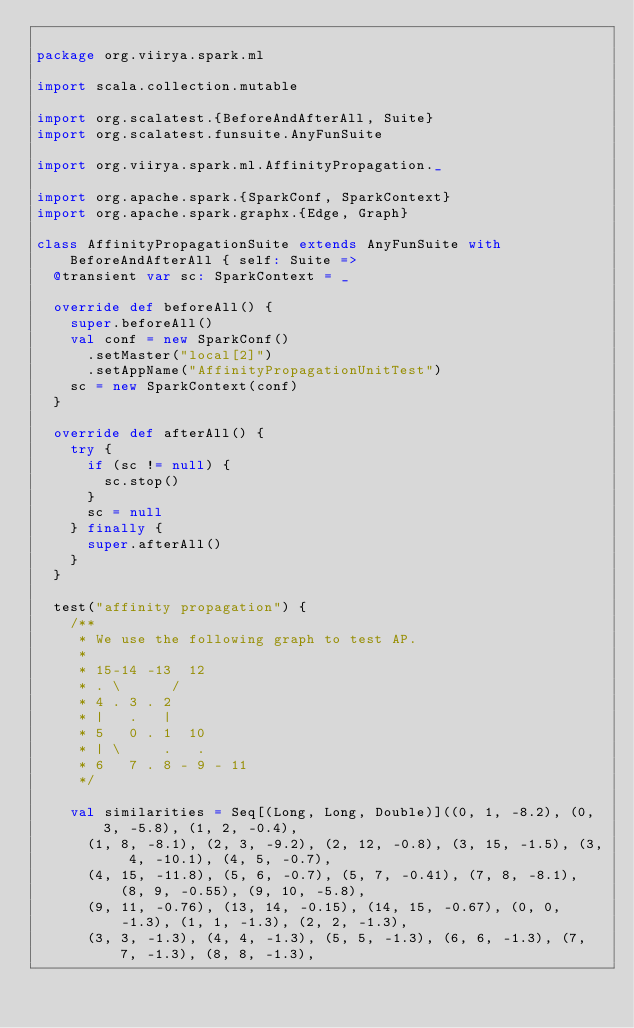Convert code to text. <code><loc_0><loc_0><loc_500><loc_500><_Scala_>
package org.viirya.spark.ml

import scala.collection.mutable

import org.scalatest.{BeforeAndAfterAll, Suite}
import org.scalatest.funsuite.AnyFunSuite

import org.viirya.spark.ml.AffinityPropagation._

import org.apache.spark.{SparkConf, SparkContext}
import org.apache.spark.graphx.{Edge, Graph}

class AffinityPropagationSuite extends AnyFunSuite with BeforeAndAfterAll { self: Suite =>
  @transient var sc: SparkContext = _

  override def beforeAll() {
    super.beforeAll()
    val conf = new SparkConf()
      .setMaster("local[2]")
      .setAppName("AffinityPropagationUnitTest")
    sc = new SparkContext(conf)
  }

  override def afterAll() {
    try {
      if (sc != null) {
        sc.stop()
      }
      sc = null
    } finally {
      super.afterAll()
    }
  }  

  test("affinity propagation") {
    /**
     * We use the following graph to test AP.
     * 
     * 15-14 -13  12
     * . \      /    
     * 4 . 3 . 2  
     * |   .   |
     * 5   0 . 1  10
     * | \     .   .
     * 6   7 . 8 - 9 - 11
     */

    val similarities = Seq[(Long, Long, Double)]((0, 1, -8.2), (0, 3, -5.8), (1, 2, -0.4),
      (1, 8, -8.1), (2, 3, -9.2), (2, 12, -0.8), (3, 15, -1.5), (3, 4, -10.1), (4, 5, -0.7),
      (4, 15, -11.8), (5, 6, -0.7), (5, 7, -0.41), (7, 8, -8.1), (8, 9, -0.55), (9, 10, -5.8),
      (9, 11, -0.76), (13, 14, -0.15), (14, 15, -0.67), (0, 0, -1.3), (1, 1, -1.3), (2, 2, -1.3),
      (3, 3, -1.3), (4, 4, -1.3), (5, 5, -1.3), (6, 6, -1.3), (7, 7, -1.3), (8, 8, -1.3),</code> 